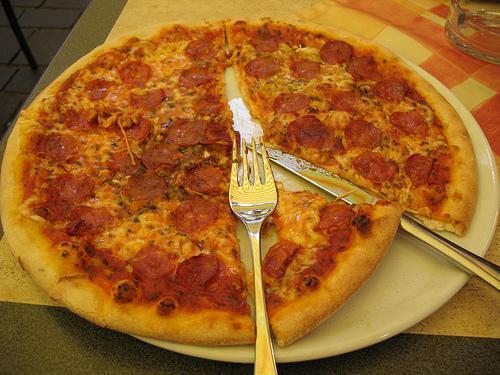How many utensils are pictured?
Give a very brief answer. 2. How many prongs does the fork have?
Give a very brief answer. 4. 